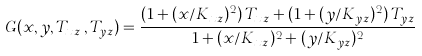<formula> <loc_0><loc_0><loc_500><loc_500>G ( x , y , T _ { x z } \, , T _ { y z } ) = \frac { ( 1 + ( x / K _ { x z } ) ^ { 2 } ) \, T _ { x z } + ( 1 + ( y / K _ { y z } ) ^ { 2 } ) \, T _ { y z } } { 1 + ( x / K _ { x z } ) ^ { 2 } + ( y / K _ { y z } ) ^ { 2 } }</formula> 